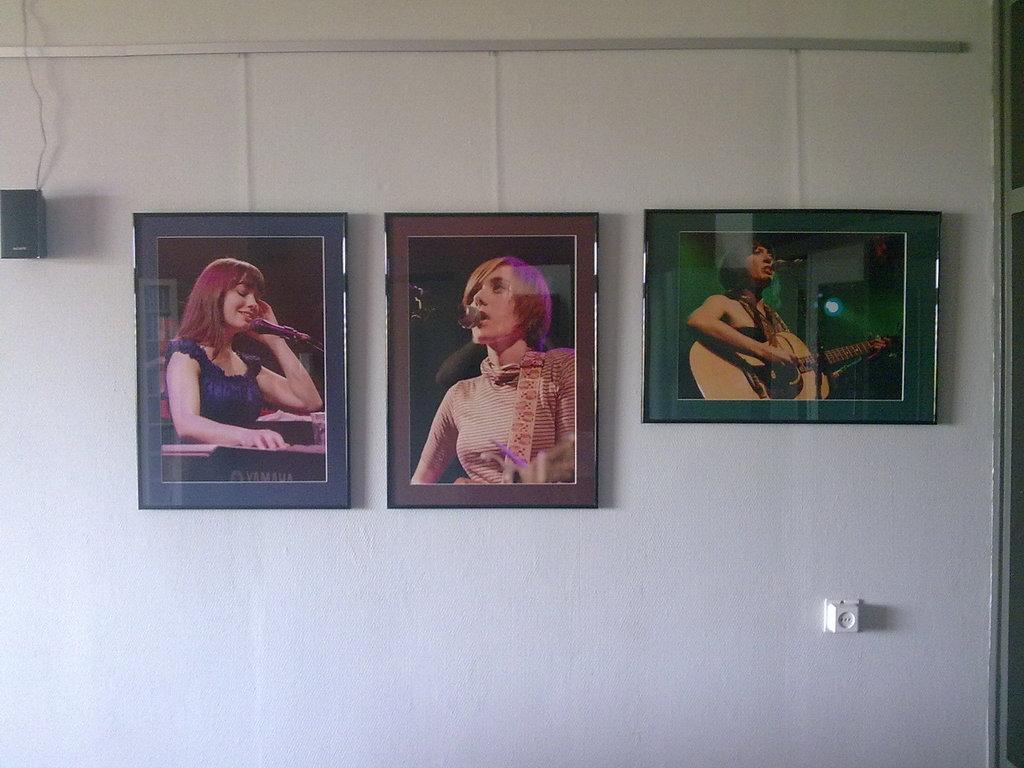Describe this image in one or two sentences. In this picture we can see few frames and a speaker on the wall. 